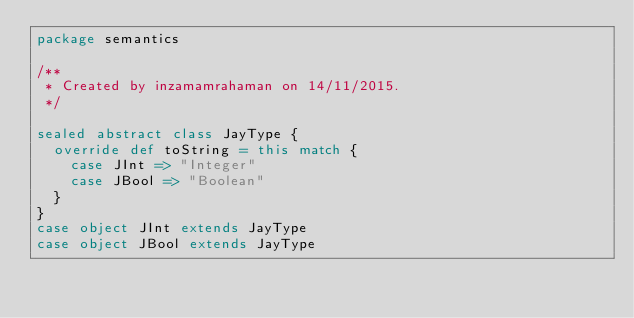Convert code to text. <code><loc_0><loc_0><loc_500><loc_500><_Scala_>package semantics

/**
 * Created by inzamamrahaman on 14/11/2015.
 */

sealed abstract class JayType {
  override def toString = this match {
    case JInt => "Integer"
    case JBool => "Boolean"
  }
}
case object JInt extends JayType
case object JBool extends JayType
</code> 